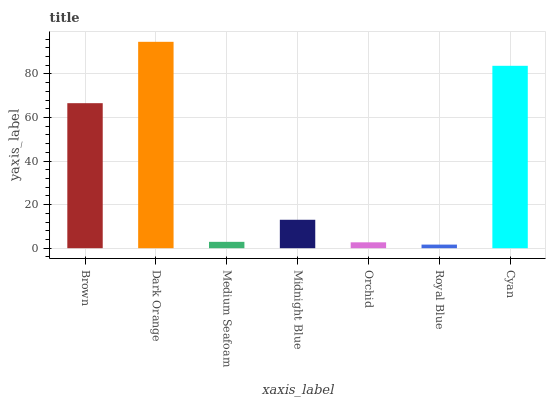Is Medium Seafoam the minimum?
Answer yes or no. No. Is Medium Seafoam the maximum?
Answer yes or no. No. Is Dark Orange greater than Medium Seafoam?
Answer yes or no. Yes. Is Medium Seafoam less than Dark Orange?
Answer yes or no. Yes. Is Medium Seafoam greater than Dark Orange?
Answer yes or no. No. Is Dark Orange less than Medium Seafoam?
Answer yes or no. No. Is Midnight Blue the high median?
Answer yes or no. Yes. Is Midnight Blue the low median?
Answer yes or no. Yes. Is Medium Seafoam the high median?
Answer yes or no. No. Is Cyan the low median?
Answer yes or no. No. 